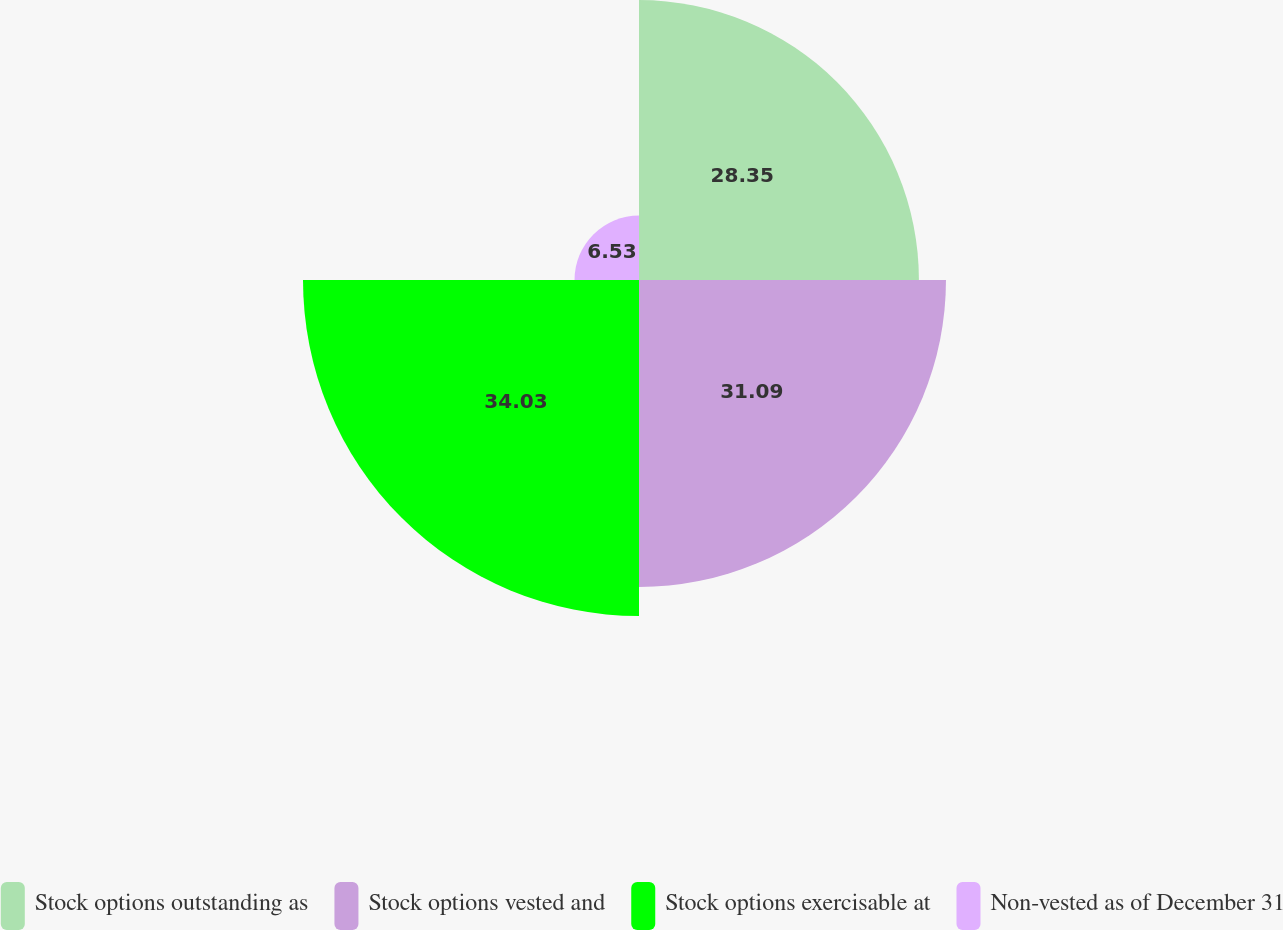<chart> <loc_0><loc_0><loc_500><loc_500><pie_chart><fcel>Stock options outstanding as<fcel>Stock options vested and<fcel>Stock options exercisable at<fcel>Non-vested as of December 31<nl><fcel>28.35%<fcel>31.09%<fcel>34.03%<fcel>6.53%<nl></chart> 